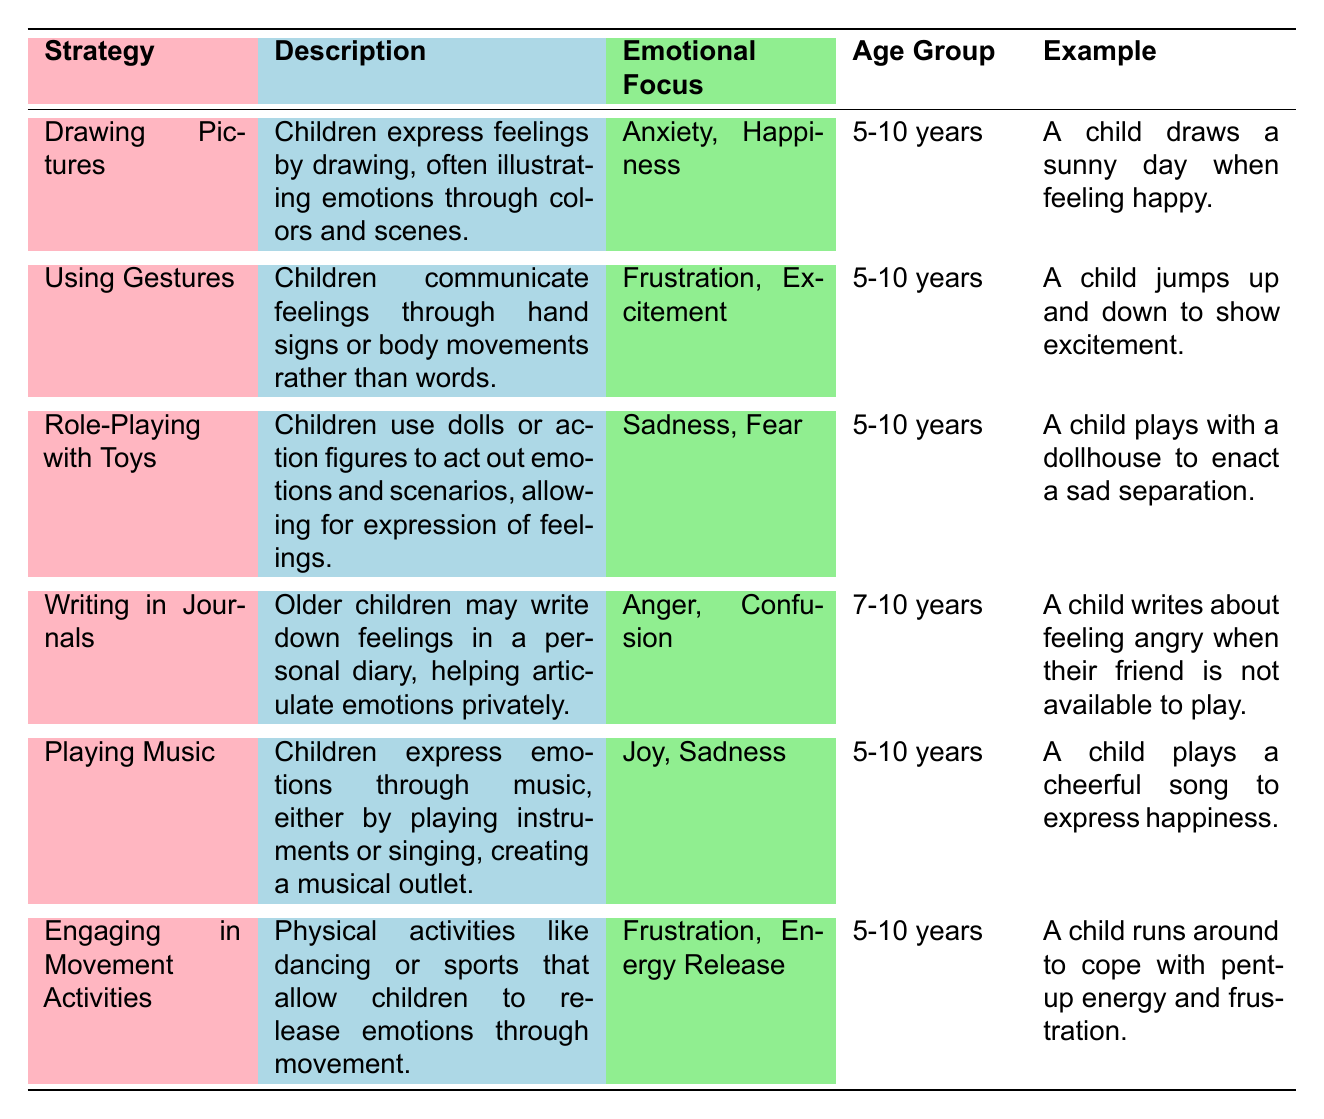What emotional focus is associated with "Drawing Pictures"? The table shows that the emotional focus for the strategy "Drawing Pictures" is Anxiety and Happiness.
Answer: Anxiety, Happiness Which age group uses the strategy of "Playing Music"? According to the table, the strategy "Playing Music" is used by children in the age group of 5-10 years.
Answer: 5-10 years Is "Writing in Journals" associated with feelings of Joy? The table indicates that "Writing in Journals" is associated with Anger and Confusion, not Joy, so the answer is no.
Answer: No How many emotional expression strategies are listed for children aged 5-10 years? There are 5 strategies listed for children aged 5-10 years: Drawing Pictures, Using Gestures, Role-Playing with Toys, Playing Music, and Engaging in Movement Activities.
Answer: 5 What are the emotional focuses for strategies used by children aged 7-10 years? The only strategy listed for this age group is "Writing in Journals," and its emotional focuses are Anger and Confusion.
Answer: Anger, Confusion Which strategies help children express frustration? The strategies "Using Gestures," "Engaging in Movement Activities," and "Writing in Journals" focus on frustration.
Answer: Using Gestures, Engaging in Movement Activities How many strategies are there that focus on both sadness and fear? The table shows that only one strategy, "Role-Playing with Toys," focuses on both sadness and fear.
Answer: 1 What strategy involves physical activities for emotion release? The "Engaging in Movement Activities" strategy involves physical activities to help release emotions.
Answer: Engaging in Movement Activities 